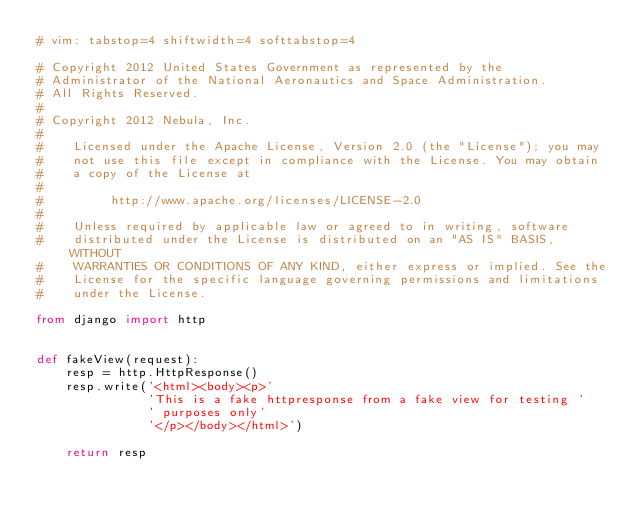Convert code to text. <code><loc_0><loc_0><loc_500><loc_500><_Python_># vim: tabstop=4 shiftwidth=4 softtabstop=4

# Copyright 2012 United States Government as represented by the
# Administrator of the National Aeronautics and Space Administration.
# All Rights Reserved.
#
# Copyright 2012 Nebula, Inc.
#
#    Licensed under the Apache License, Version 2.0 (the "License"); you may
#    not use this file except in compliance with the License. You may obtain
#    a copy of the License at
#
#         http://www.apache.org/licenses/LICENSE-2.0
#
#    Unless required by applicable law or agreed to in writing, software
#    distributed under the License is distributed on an "AS IS" BASIS, WITHOUT
#    WARRANTIES OR CONDITIONS OF ANY KIND, either express or implied. See the
#    License for the specific language governing permissions and limitations
#    under the License.

from django import http


def fakeView(request):
    resp = http.HttpResponse()
    resp.write('<html><body><p>'
               'This is a fake httpresponse from a fake view for testing '
               ' purposes only'
               '</p></body></html>')

    return resp
</code> 